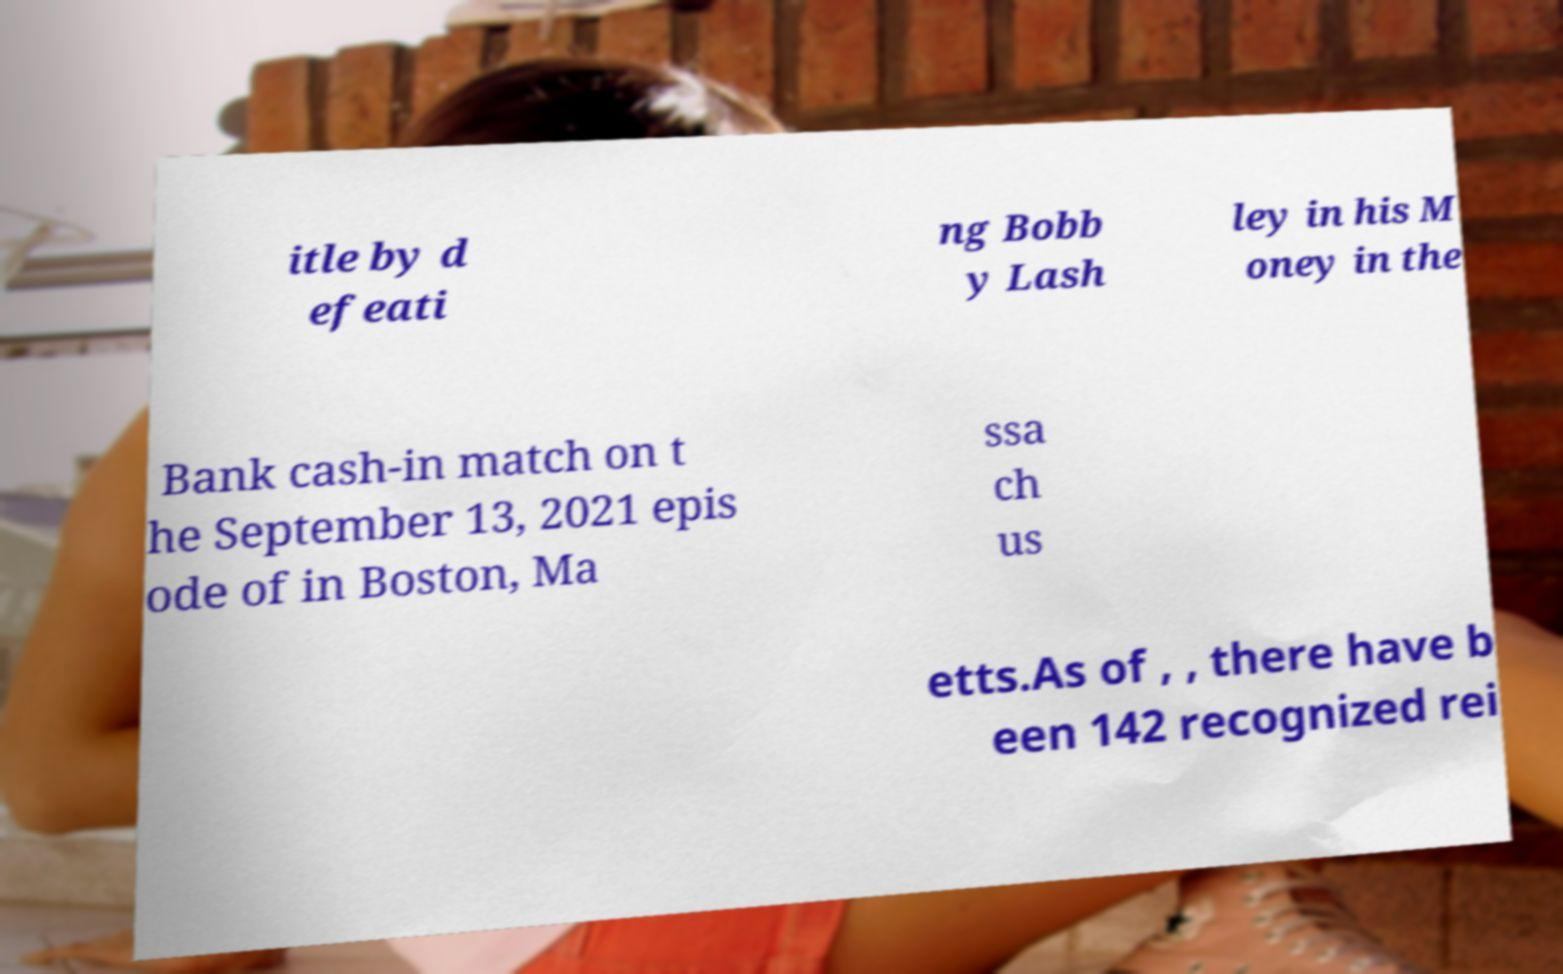Can you read and provide the text displayed in the image?This photo seems to have some interesting text. Can you extract and type it out for me? itle by d efeati ng Bobb y Lash ley in his M oney in the Bank cash-in match on t he September 13, 2021 epis ode of in Boston, Ma ssa ch us etts.As of , , there have b een 142 recognized rei 